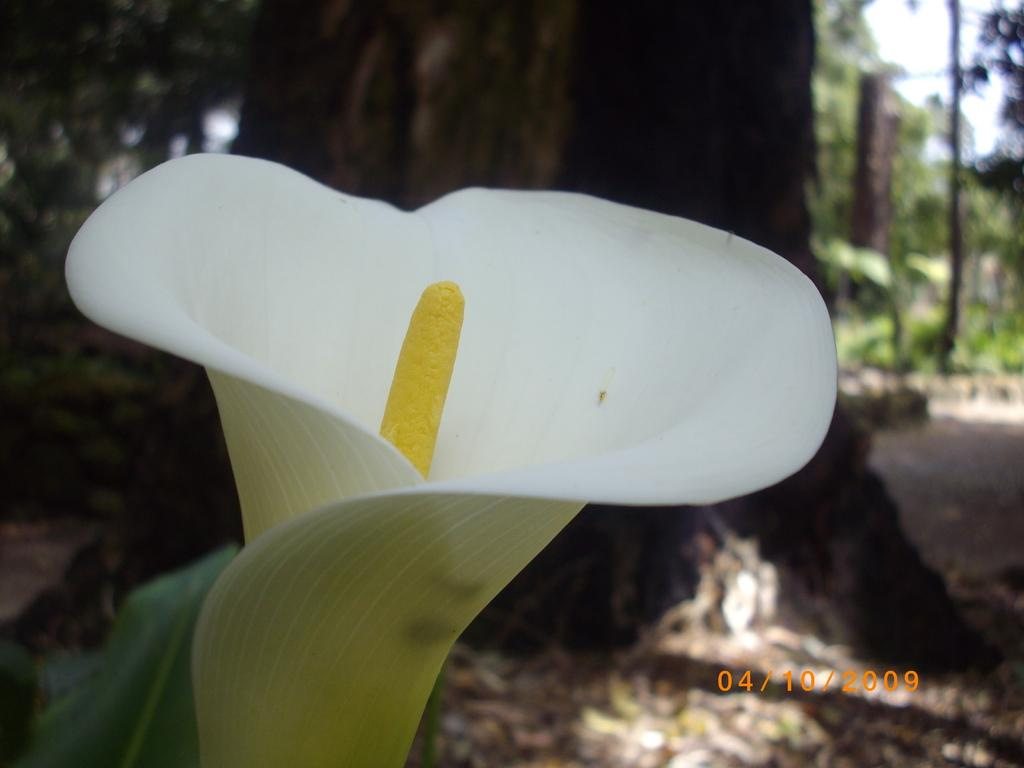What is the main subject of the image? There is a flower in the image. Can you describe the color of the flower? The flower is white. What can be seen in the background of the image? There are trees and the sky visible in the background of the image. How does the baby shake the flower in the image? There is no baby present in the image, and therefore no such action can be observed. 